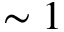Convert formula to latex. <formula><loc_0><loc_0><loc_500><loc_500>\sim 1</formula> 